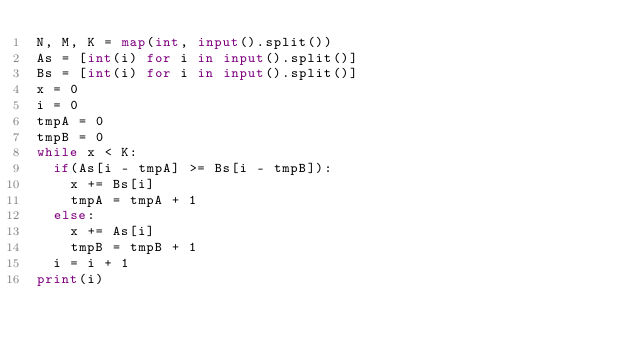<code> <loc_0><loc_0><loc_500><loc_500><_Python_>N, M, K = map(int, input().split())
As = [int(i) for i in input().split()]
Bs = [int(i) for i in input().split()]
x = 0
i = 0
tmpA = 0
tmpB = 0
while x < K:
  if(As[i - tmpA] >= Bs[i - tmpB]):
    x += Bs[i]
    tmpA = tmpA + 1
  else:
    x += As[i]
    tmpB = tmpB + 1
  i = i + 1
print(i)</code> 